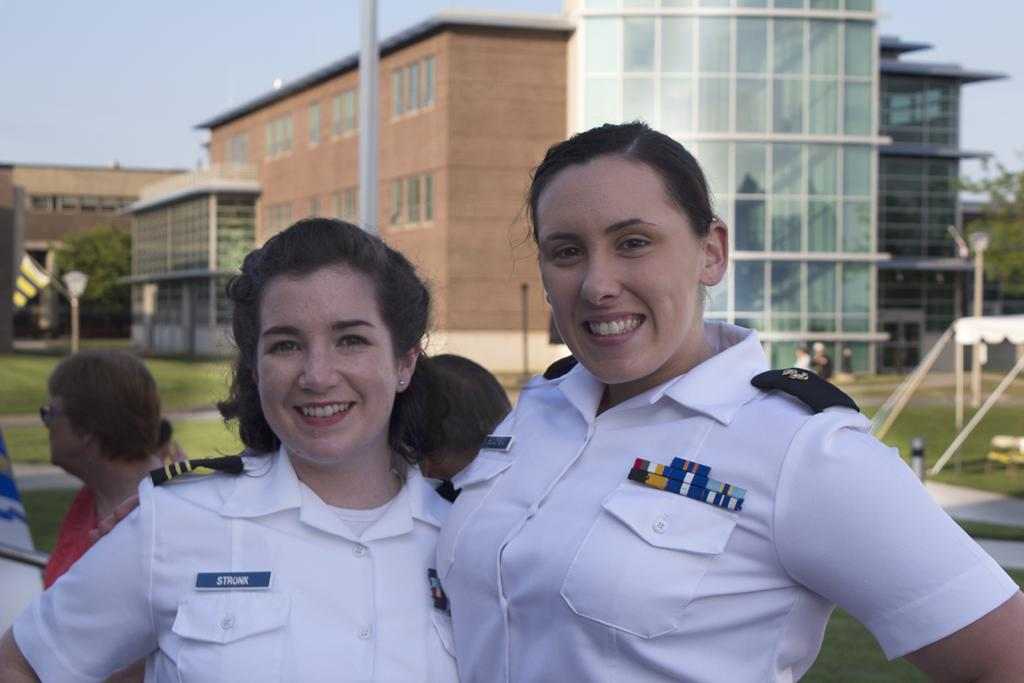How many people are in the image? There are two women in the image. What is the facial expression of the women? The women are smiling. What type of terrain is visible in the image? There is green grass in the image. What can be seen in the distance in the image? There are buildings in the background of the image. What is visible in the sky in the image? Clouds are visible in the sky. What type of bait is the woman on the left using to catch fish in the image? There is no fishing or bait present in the image; it features two women smiling in a grassy area with buildings in the background. What are the names of the women in the image? We cannot determine the names of the women in the image based on the provided facts. 